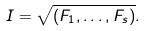<formula> <loc_0><loc_0><loc_500><loc_500>I = \sqrt { ( F _ { 1 } , \dots , F _ { s } ) } .</formula> 